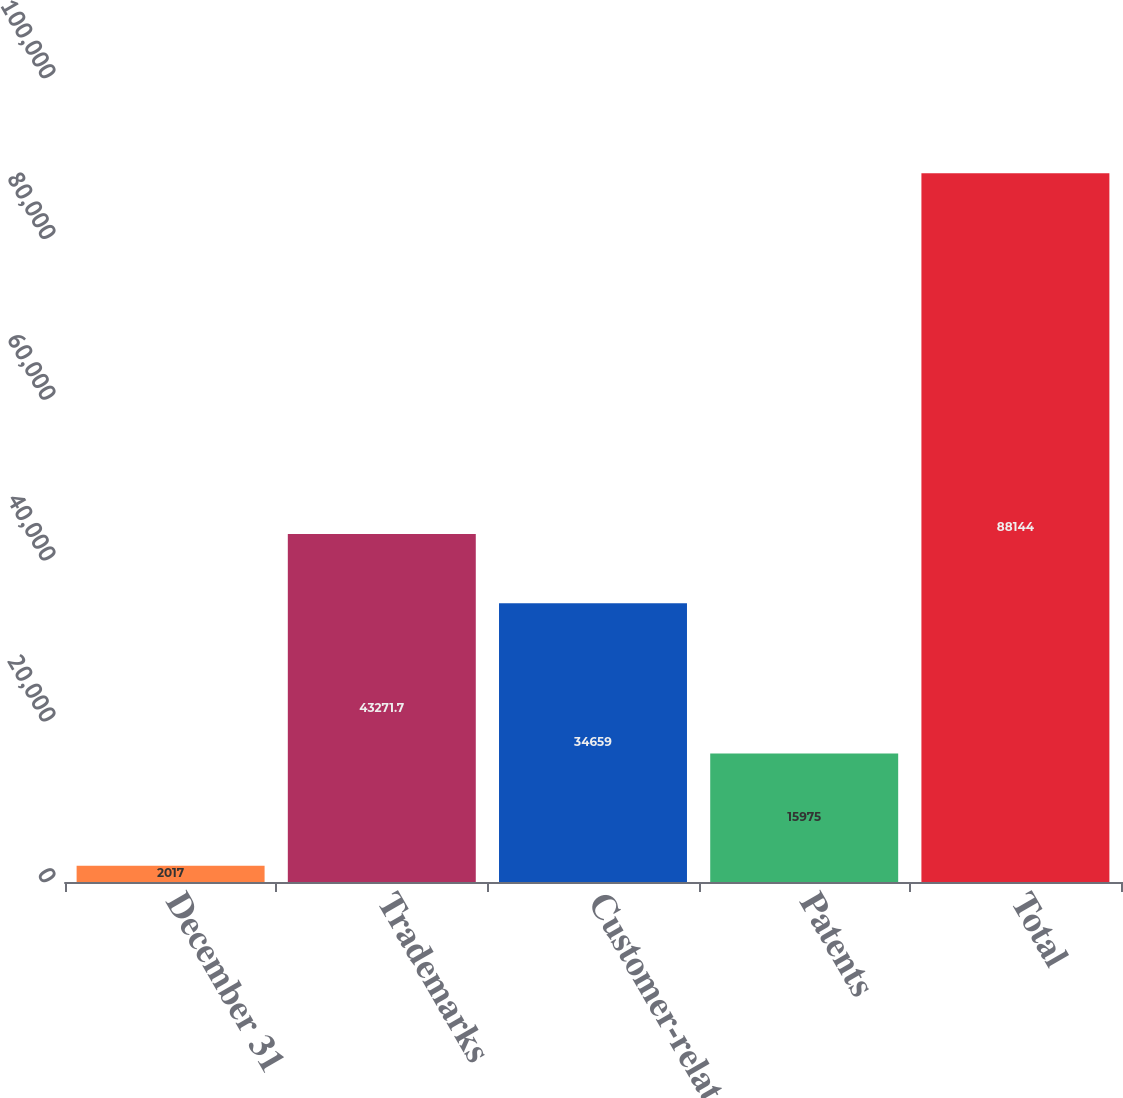<chart> <loc_0><loc_0><loc_500><loc_500><bar_chart><fcel>December 31<fcel>Trademarks<fcel>Customer-related<fcel>Patents<fcel>Total<nl><fcel>2017<fcel>43271.7<fcel>34659<fcel>15975<fcel>88144<nl></chart> 